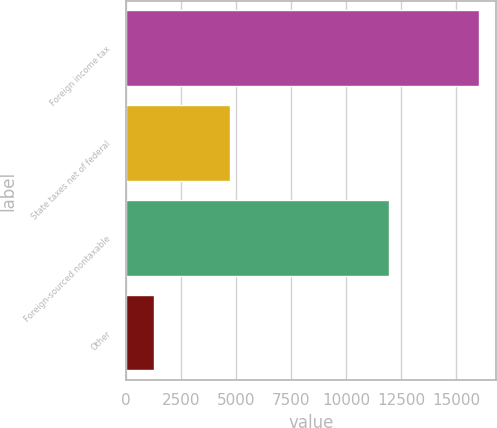<chart> <loc_0><loc_0><loc_500><loc_500><bar_chart><fcel>Foreign income tax<fcel>State taxes net of federal<fcel>Foreign-sourced nontaxable<fcel>Other<nl><fcel>16021<fcel>4744<fcel>11967<fcel>1285<nl></chart> 